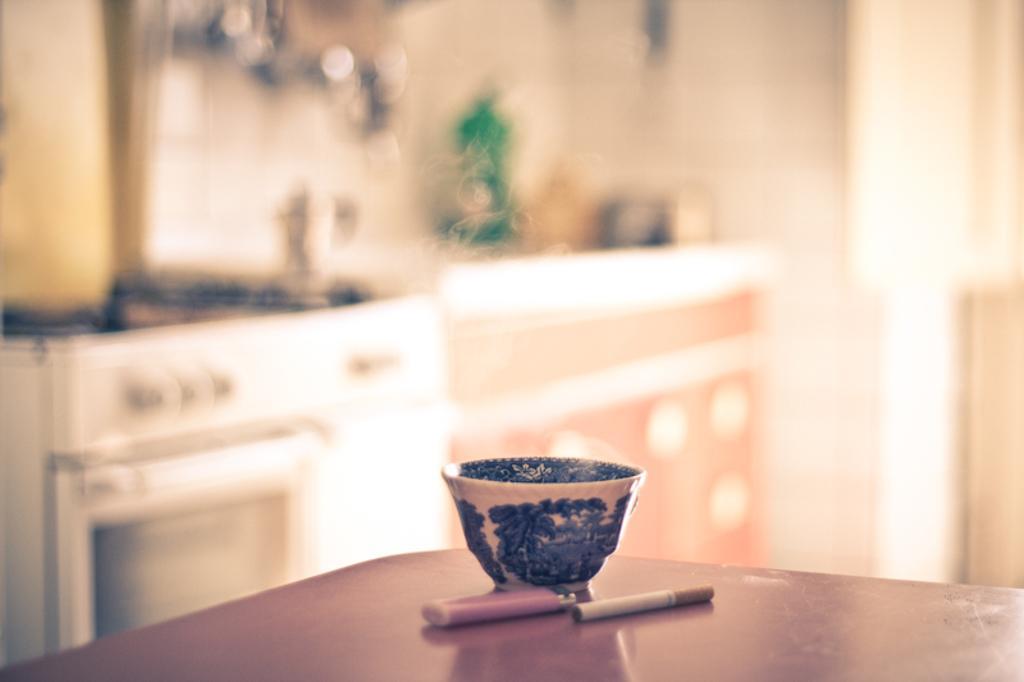Please provide a concise description of this image. This is picture taken in a room. This is a table on the table there is a bowl, lighter and cigarette. Background of this table is a wall and it is in blue. 